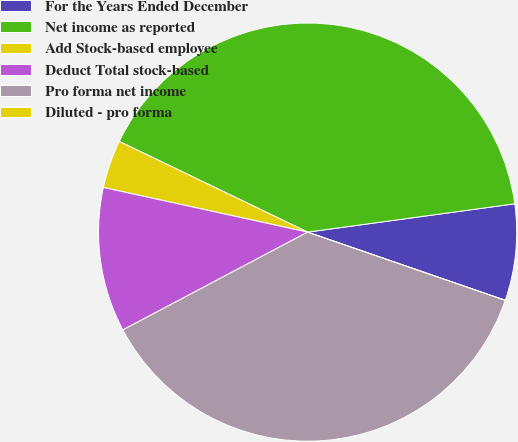<chart> <loc_0><loc_0><loc_500><loc_500><pie_chart><fcel>For the Years Ended December<fcel>Net income as reported<fcel>Add Stock-based employee<fcel>Deduct Total stock-based<fcel>Pro forma net income<fcel>Diluted - pro forma<nl><fcel>7.45%<fcel>40.69%<fcel>3.72%<fcel>11.17%<fcel>36.96%<fcel>0.0%<nl></chart> 